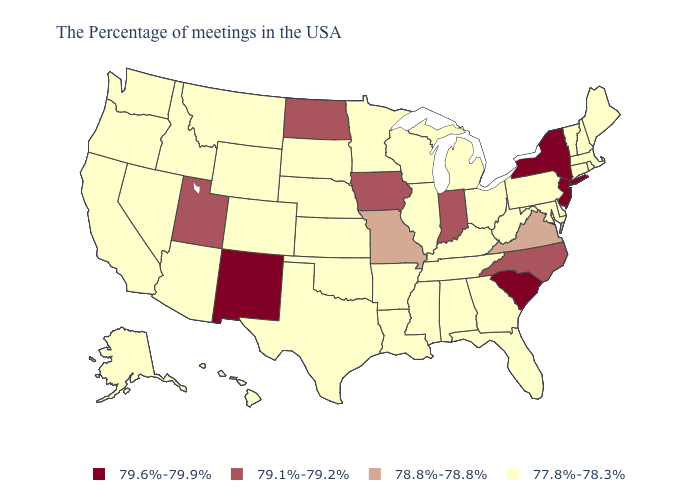Among the states that border South Dakota , does Montana have the lowest value?
Quick response, please. Yes. Does the first symbol in the legend represent the smallest category?
Be succinct. No. Does the map have missing data?
Be succinct. No. Among the states that border Montana , which have the lowest value?
Give a very brief answer. South Dakota, Wyoming, Idaho. What is the lowest value in the USA?
Concise answer only. 77.8%-78.3%. Does Hawaii have the same value as Indiana?
Quick response, please. No. What is the value of Pennsylvania?
Answer briefly. 77.8%-78.3%. Name the states that have a value in the range 78.8%-78.8%?
Quick response, please. Virginia, Missouri. Which states have the lowest value in the South?
Be succinct. Delaware, Maryland, West Virginia, Florida, Georgia, Kentucky, Alabama, Tennessee, Mississippi, Louisiana, Arkansas, Oklahoma, Texas. Which states have the lowest value in the Northeast?
Be succinct. Maine, Massachusetts, Rhode Island, New Hampshire, Vermont, Connecticut, Pennsylvania. Which states have the lowest value in the USA?
Write a very short answer. Maine, Massachusetts, Rhode Island, New Hampshire, Vermont, Connecticut, Delaware, Maryland, Pennsylvania, West Virginia, Ohio, Florida, Georgia, Michigan, Kentucky, Alabama, Tennessee, Wisconsin, Illinois, Mississippi, Louisiana, Arkansas, Minnesota, Kansas, Nebraska, Oklahoma, Texas, South Dakota, Wyoming, Colorado, Montana, Arizona, Idaho, Nevada, California, Washington, Oregon, Alaska, Hawaii. Does the first symbol in the legend represent the smallest category?
Be succinct. No. Among the states that border Kentucky , does Missouri have the lowest value?
Short answer required. No. What is the value of New Mexico?
Keep it brief. 79.6%-79.9%. 